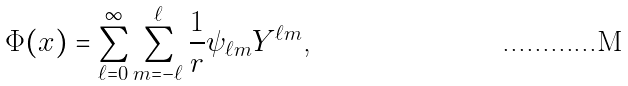<formula> <loc_0><loc_0><loc_500><loc_500>\Phi ( x ) & = \sum _ { \ell = 0 } ^ { \infty } \sum _ { m = - \ell } ^ { \ell } \frac { 1 } { r } \psi _ { \ell m } Y ^ { \ell m } \text {,}</formula> 